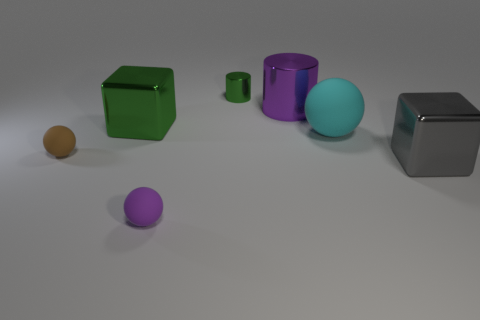There is a rubber sphere on the right side of the purple metallic cylinder; what is its size?
Provide a succinct answer. Large. How many other matte spheres have the same size as the brown rubber sphere?
Provide a succinct answer. 1. What is the material of the object that is both left of the large metal cylinder and in front of the tiny brown matte sphere?
Keep it short and to the point. Rubber. There is a cylinder that is the same size as the purple matte ball; what material is it?
Provide a short and direct response. Metal. There is a matte ball in front of the big shiny block that is on the right side of the ball behind the brown matte ball; how big is it?
Ensure brevity in your answer.  Small. There is a cyan object that is made of the same material as the tiny brown sphere; what is its size?
Your answer should be very brief. Large. Does the brown rubber thing have the same size as the ball in front of the big gray block?
Offer a terse response. Yes. The shiny object left of the small cylinder has what shape?
Your response must be concise. Cube. Is there a shiny cylinder in front of the small metallic cylinder to the left of the block that is to the right of the purple rubber ball?
Your response must be concise. Yes. There is a tiny purple object that is the same shape as the cyan thing; what material is it?
Give a very brief answer. Rubber. 